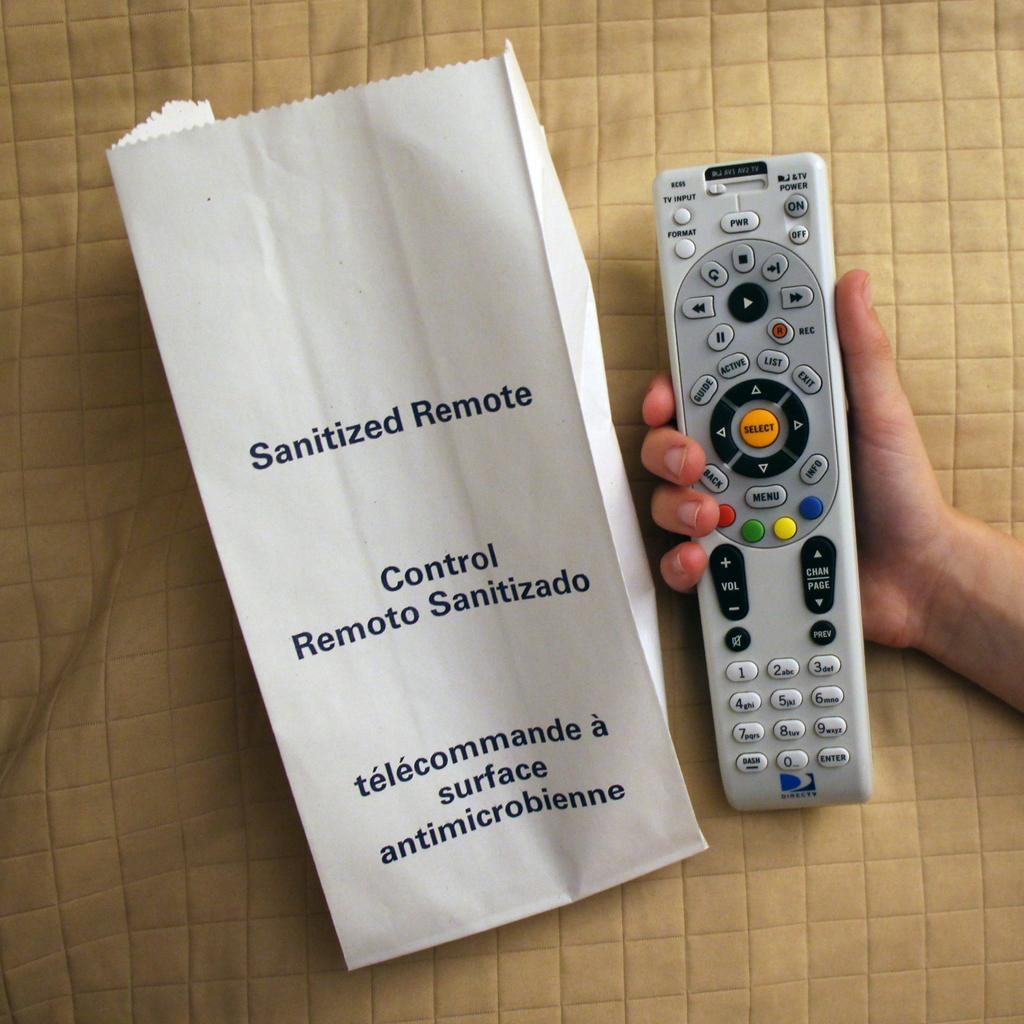<image>
Create a compact narrative representing the image presented. A remote being held next to a paper bag that says sanitized remote on it. 